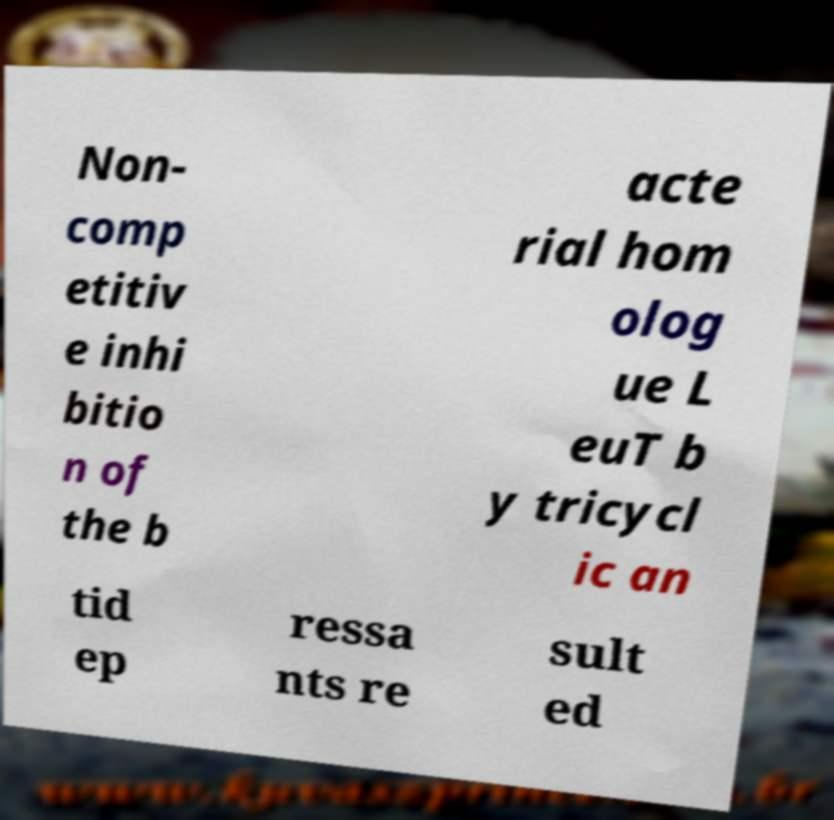What messages or text are displayed in this image? I need them in a readable, typed format. Non- comp etitiv e inhi bitio n of the b acte rial hom olog ue L euT b y tricycl ic an tid ep ressa nts re sult ed 